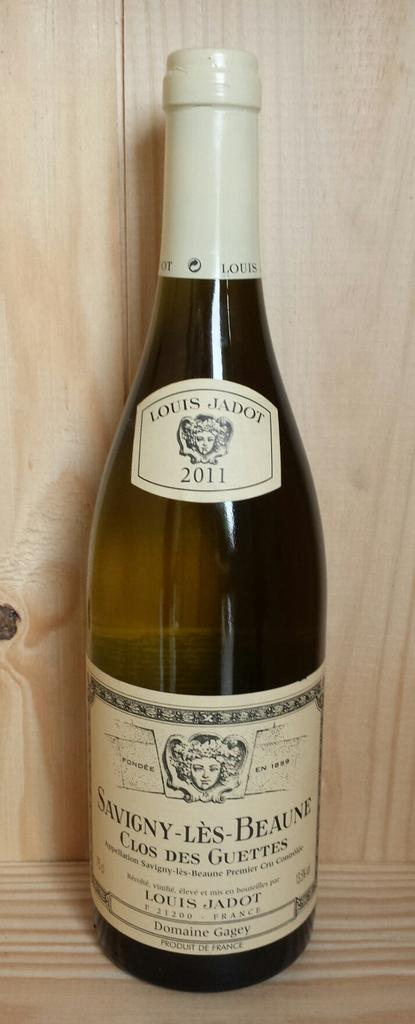<image>
Write a terse but informative summary of the picture. A glass of wine with French writing on the front of it. 